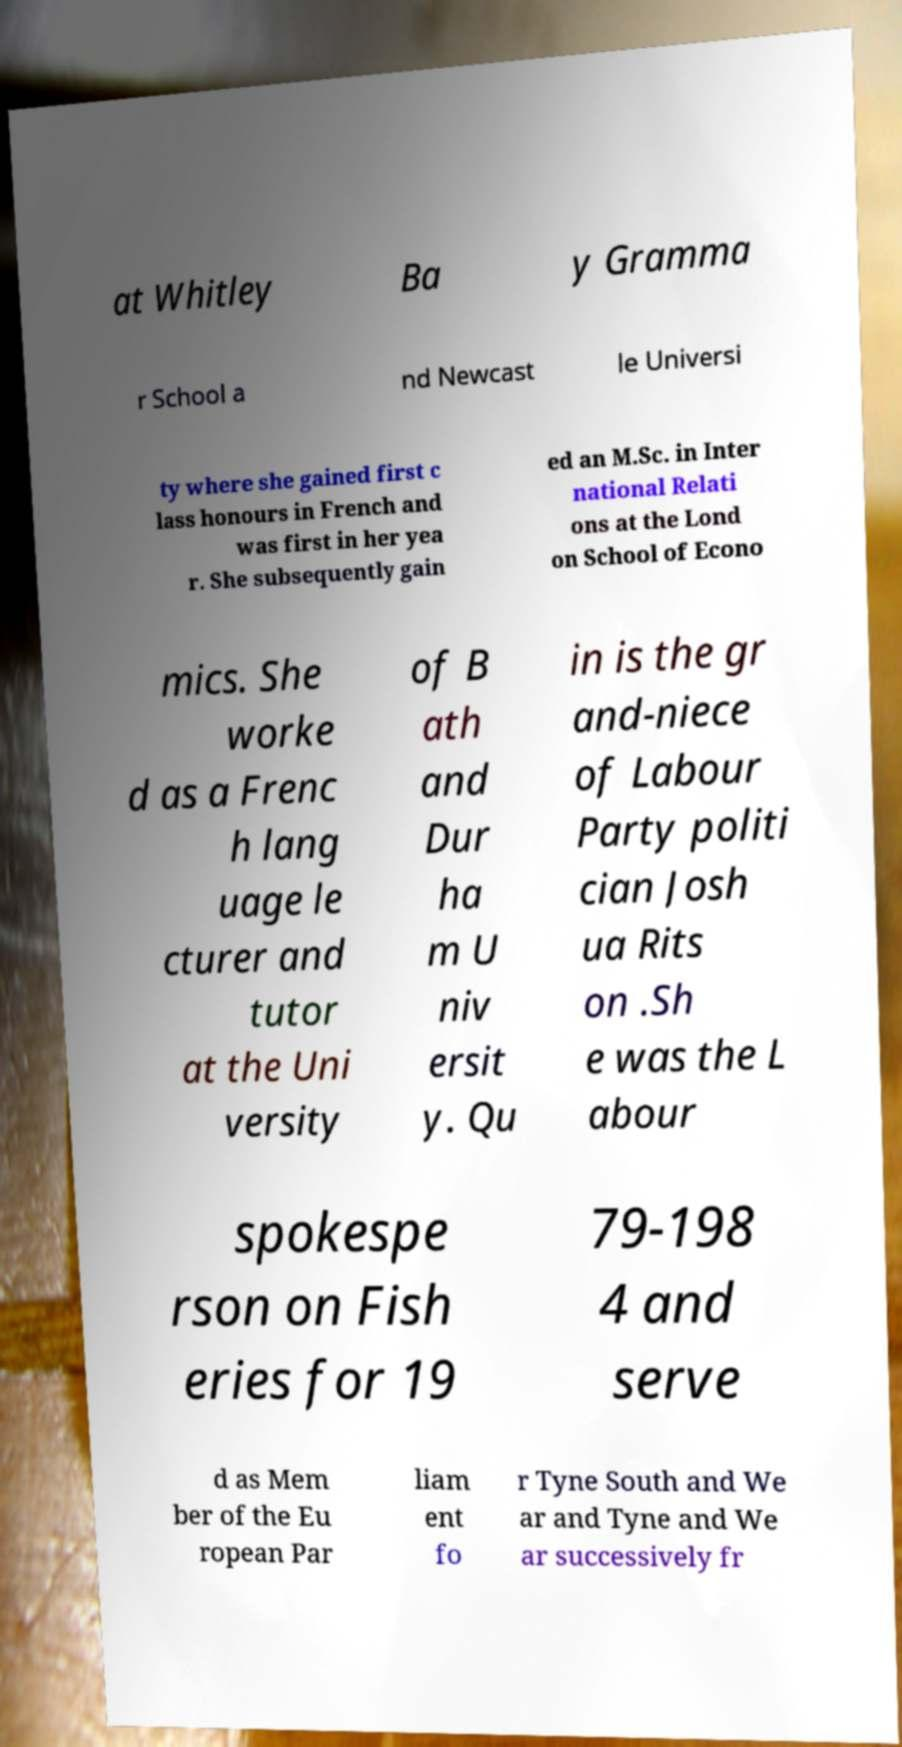Can you accurately transcribe the text from the provided image for me? at Whitley Ba y Gramma r School a nd Newcast le Universi ty where she gained first c lass honours in French and was first in her yea r. She subsequently gain ed an M.Sc. in Inter national Relati ons at the Lond on School of Econo mics. She worke d as a Frenc h lang uage le cturer and tutor at the Uni versity of B ath and Dur ha m U niv ersit y. Qu in is the gr and-niece of Labour Party politi cian Josh ua Rits on .Sh e was the L abour spokespe rson on Fish eries for 19 79-198 4 and serve d as Mem ber of the Eu ropean Par liam ent fo r Tyne South and We ar and Tyne and We ar successively fr 